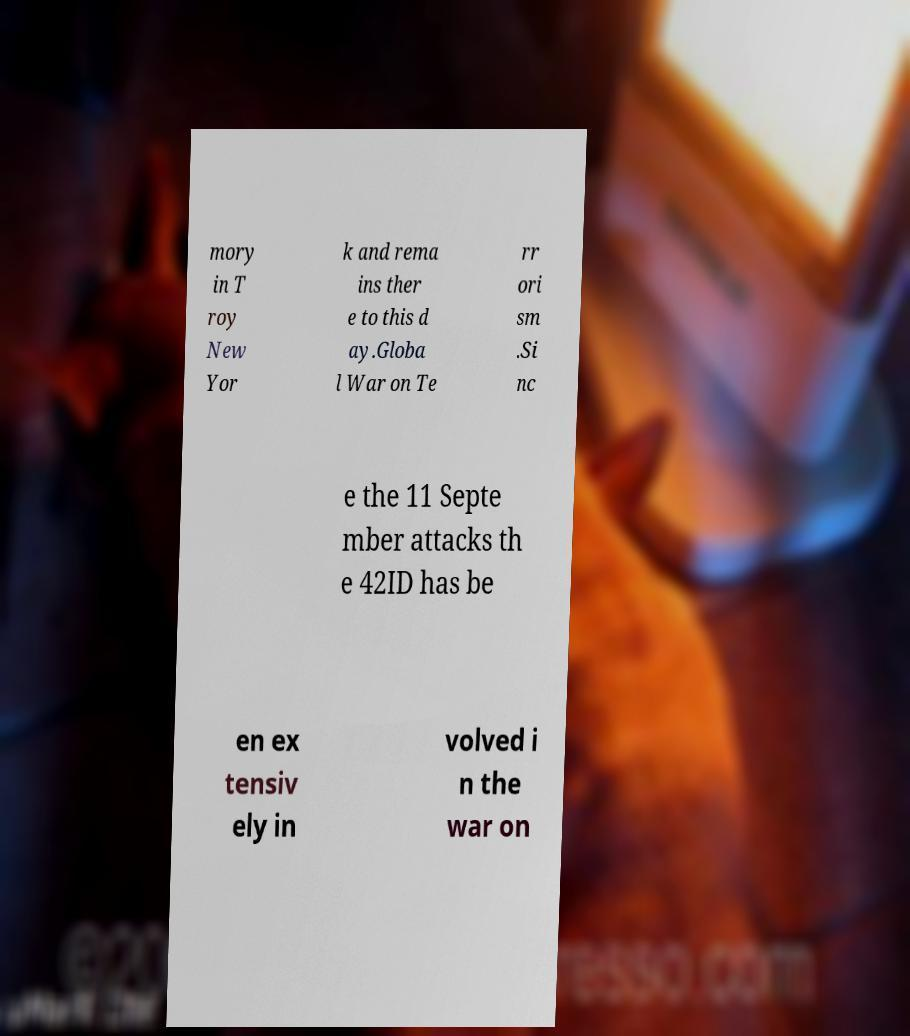Please identify and transcribe the text found in this image. mory in T roy New Yor k and rema ins ther e to this d ay.Globa l War on Te rr ori sm .Si nc e the 11 Septe mber attacks th e 42ID has be en ex tensiv ely in volved i n the war on 